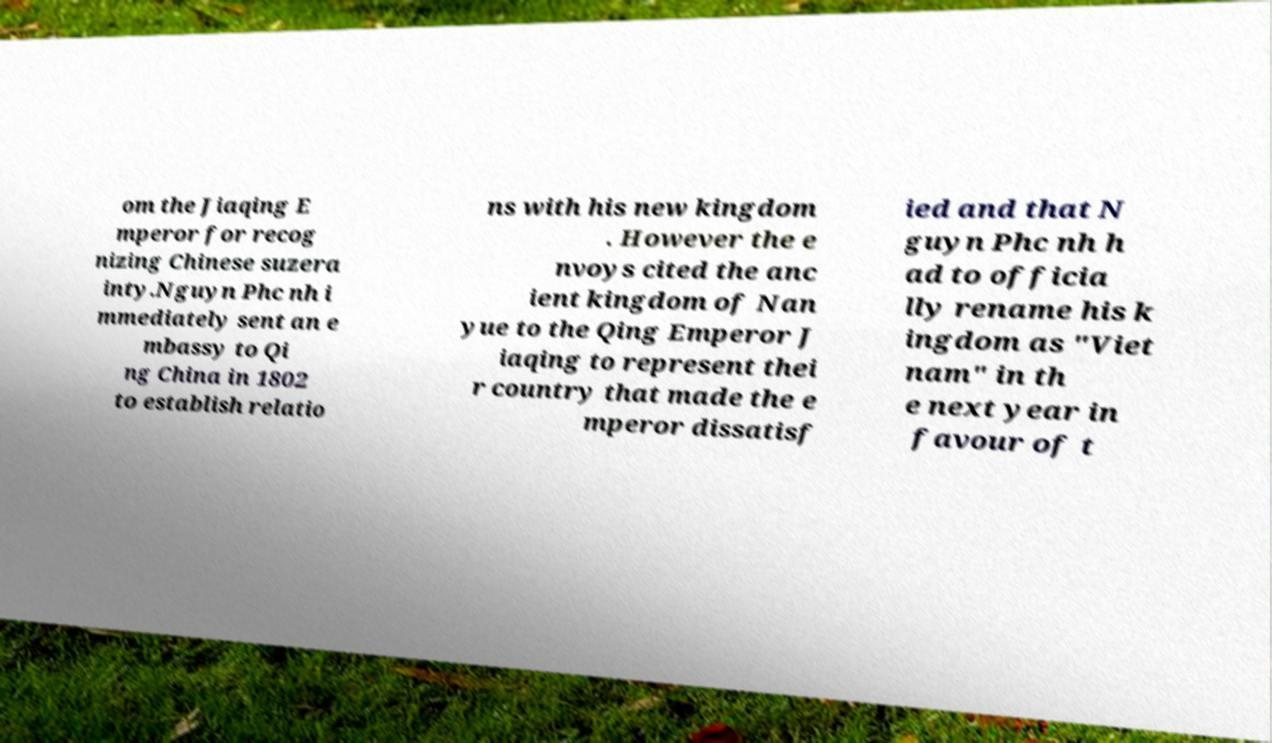Could you extract and type out the text from this image? om the Jiaqing E mperor for recog nizing Chinese suzera inty.Nguyn Phc nh i mmediately sent an e mbassy to Qi ng China in 1802 to establish relatio ns with his new kingdom . However the e nvoys cited the anc ient kingdom of Nan yue to the Qing Emperor J iaqing to represent thei r country that made the e mperor dissatisf ied and that N guyn Phc nh h ad to officia lly rename his k ingdom as "Viet nam" in th e next year in favour of t 